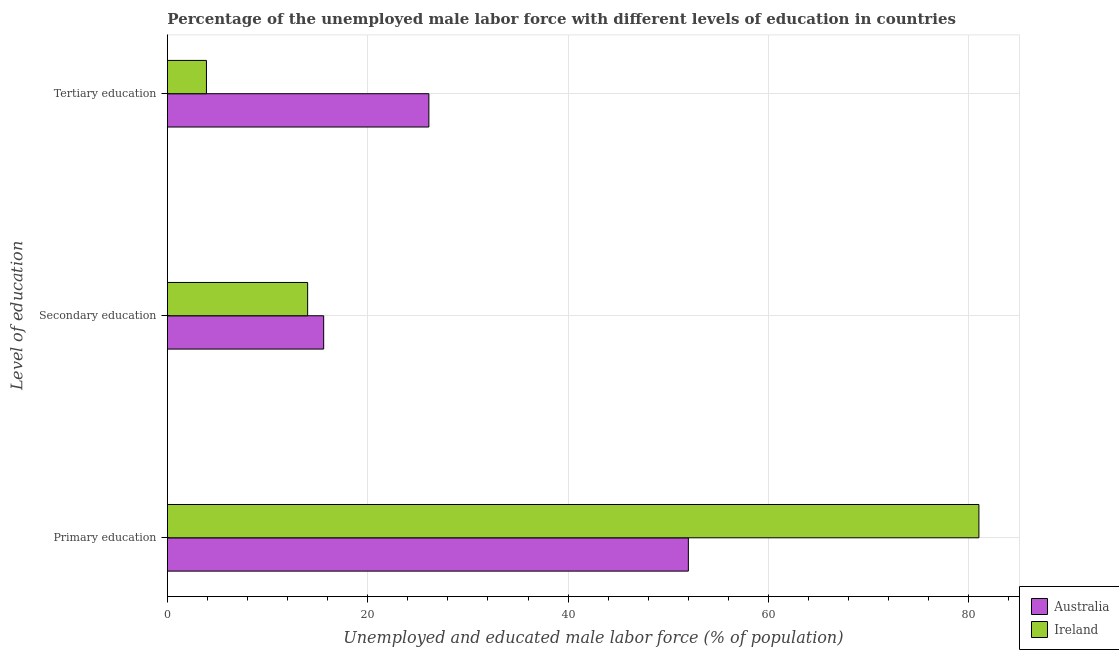How many different coloured bars are there?
Offer a very short reply. 2. How many groups of bars are there?
Make the answer very short. 3. What is the label of the 2nd group of bars from the top?
Your response must be concise. Secondary education. What is the percentage of male labor force who received tertiary education in Ireland?
Offer a terse response. 3.9. Across all countries, what is the maximum percentage of male labor force who received tertiary education?
Your answer should be very brief. 26.1. In which country was the percentage of male labor force who received tertiary education minimum?
Give a very brief answer. Ireland. What is the total percentage of male labor force who received primary education in the graph?
Provide a succinct answer. 133. What is the difference between the percentage of male labor force who received secondary education in Australia and the percentage of male labor force who received primary education in Ireland?
Your answer should be compact. -65.4. What is the average percentage of male labor force who received secondary education per country?
Offer a terse response. 14.8. What is the difference between the percentage of male labor force who received tertiary education and percentage of male labor force who received primary education in Ireland?
Your answer should be very brief. -77.1. In how many countries, is the percentage of male labor force who received secondary education greater than 64 %?
Give a very brief answer. 0. What is the ratio of the percentage of male labor force who received primary education in Australia to that in Ireland?
Give a very brief answer. 0.64. Is the difference between the percentage of male labor force who received primary education in Australia and Ireland greater than the difference between the percentage of male labor force who received tertiary education in Australia and Ireland?
Your answer should be compact. No. What is the difference between the highest and the second highest percentage of male labor force who received secondary education?
Make the answer very short. 1.6. What is the difference between the highest and the lowest percentage of male labor force who received secondary education?
Keep it short and to the point. 1.6. What does the 1st bar from the top in Tertiary education represents?
Your response must be concise. Ireland. What does the 2nd bar from the bottom in Secondary education represents?
Offer a very short reply. Ireland. Is it the case that in every country, the sum of the percentage of male labor force who received primary education and percentage of male labor force who received secondary education is greater than the percentage of male labor force who received tertiary education?
Make the answer very short. Yes. How many bars are there?
Provide a short and direct response. 6. Are all the bars in the graph horizontal?
Offer a terse response. Yes. How many countries are there in the graph?
Your answer should be compact. 2. Are the values on the major ticks of X-axis written in scientific E-notation?
Ensure brevity in your answer.  No. Does the graph contain grids?
Your answer should be compact. Yes. What is the title of the graph?
Ensure brevity in your answer.  Percentage of the unemployed male labor force with different levels of education in countries. What is the label or title of the X-axis?
Your answer should be compact. Unemployed and educated male labor force (% of population). What is the label or title of the Y-axis?
Provide a succinct answer. Level of education. What is the Unemployed and educated male labor force (% of population) of Australia in Primary education?
Provide a short and direct response. 52. What is the Unemployed and educated male labor force (% of population) in Ireland in Primary education?
Your answer should be compact. 81. What is the Unemployed and educated male labor force (% of population) of Australia in Secondary education?
Give a very brief answer. 15.6. What is the Unemployed and educated male labor force (% of population) of Ireland in Secondary education?
Your answer should be compact. 14. What is the Unemployed and educated male labor force (% of population) of Australia in Tertiary education?
Make the answer very short. 26.1. What is the Unemployed and educated male labor force (% of population) of Ireland in Tertiary education?
Give a very brief answer. 3.9. Across all Level of education, what is the maximum Unemployed and educated male labor force (% of population) in Ireland?
Ensure brevity in your answer.  81. Across all Level of education, what is the minimum Unemployed and educated male labor force (% of population) in Australia?
Offer a terse response. 15.6. Across all Level of education, what is the minimum Unemployed and educated male labor force (% of population) of Ireland?
Offer a terse response. 3.9. What is the total Unemployed and educated male labor force (% of population) in Australia in the graph?
Make the answer very short. 93.7. What is the total Unemployed and educated male labor force (% of population) of Ireland in the graph?
Offer a terse response. 98.9. What is the difference between the Unemployed and educated male labor force (% of population) in Australia in Primary education and that in Secondary education?
Ensure brevity in your answer.  36.4. What is the difference between the Unemployed and educated male labor force (% of population) in Australia in Primary education and that in Tertiary education?
Offer a very short reply. 25.9. What is the difference between the Unemployed and educated male labor force (% of population) of Ireland in Primary education and that in Tertiary education?
Offer a very short reply. 77.1. What is the difference between the Unemployed and educated male labor force (% of population) in Australia in Primary education and the Unemployed and educated male labor force (% of population) in Ireland in Tertiary education?
Offer a terse response. 48.1. What is the average Unemployed and educated male labor force (% of population) of Australia per Level of education?
Ensure brevity in your answer.  31.23. What is the average Unemployed and educated male labor force (% of population) of Ireland per Level of education?
Your response must be concise. 32.97. What is the difference between the Unemployed and educated male labor force (% of population) of Australia and Unemployed and educated male labor force (% of population) of Ireland in Primary education?
Your answer should be very brief. -29. What is the difference between the Unemployed and educated male labor force (% of population) of Australia and Unemployed and educated male labor force (% of population) of Ireland in Tertiary education?
Your answer should be compact. 22.2. What is the ratio of the Unemployed and educated male labor force (% of population) of Ireland in Primary education to that in Secondary education?
Ensure brevity in your answer.  5.79. What is the ratio of the Unemployed and educated male labor force (% of population) of Australia in Primary education to that in Tertiary education?
Offer a terse response. 1.99. What is the ratio of the Unemployed and educated male labor force (% of population) of Ireland in Primary education to that in Tertiary education?
Make the answer very short. 20.77. What is the ratio of the Unemployed and educated male labor force (% of population) in Australia in Secondary education to that in Tertiary education?
Offer a very short reply. 0.6. What is the ratio of the Unemployed and educated male labor force (% of population) of Ireland in Secondary education to that in Tertiary education?
Make the answer very short. 3.59. What is the difference between the highest and the second highest Unemployed and educated male labor force (% of population) of Australia?
Provide a succinct answer. 25.9. What is the difference between the highest and the lowest Unemployed and educated male labor force (% of population) in Australia?
Offer a very short reply. 36.4. What is the difference between the highest and the lowest Unemployed and educated male labor force (% of population) of Ireland?
Provide a succinct answer. 77.1. 